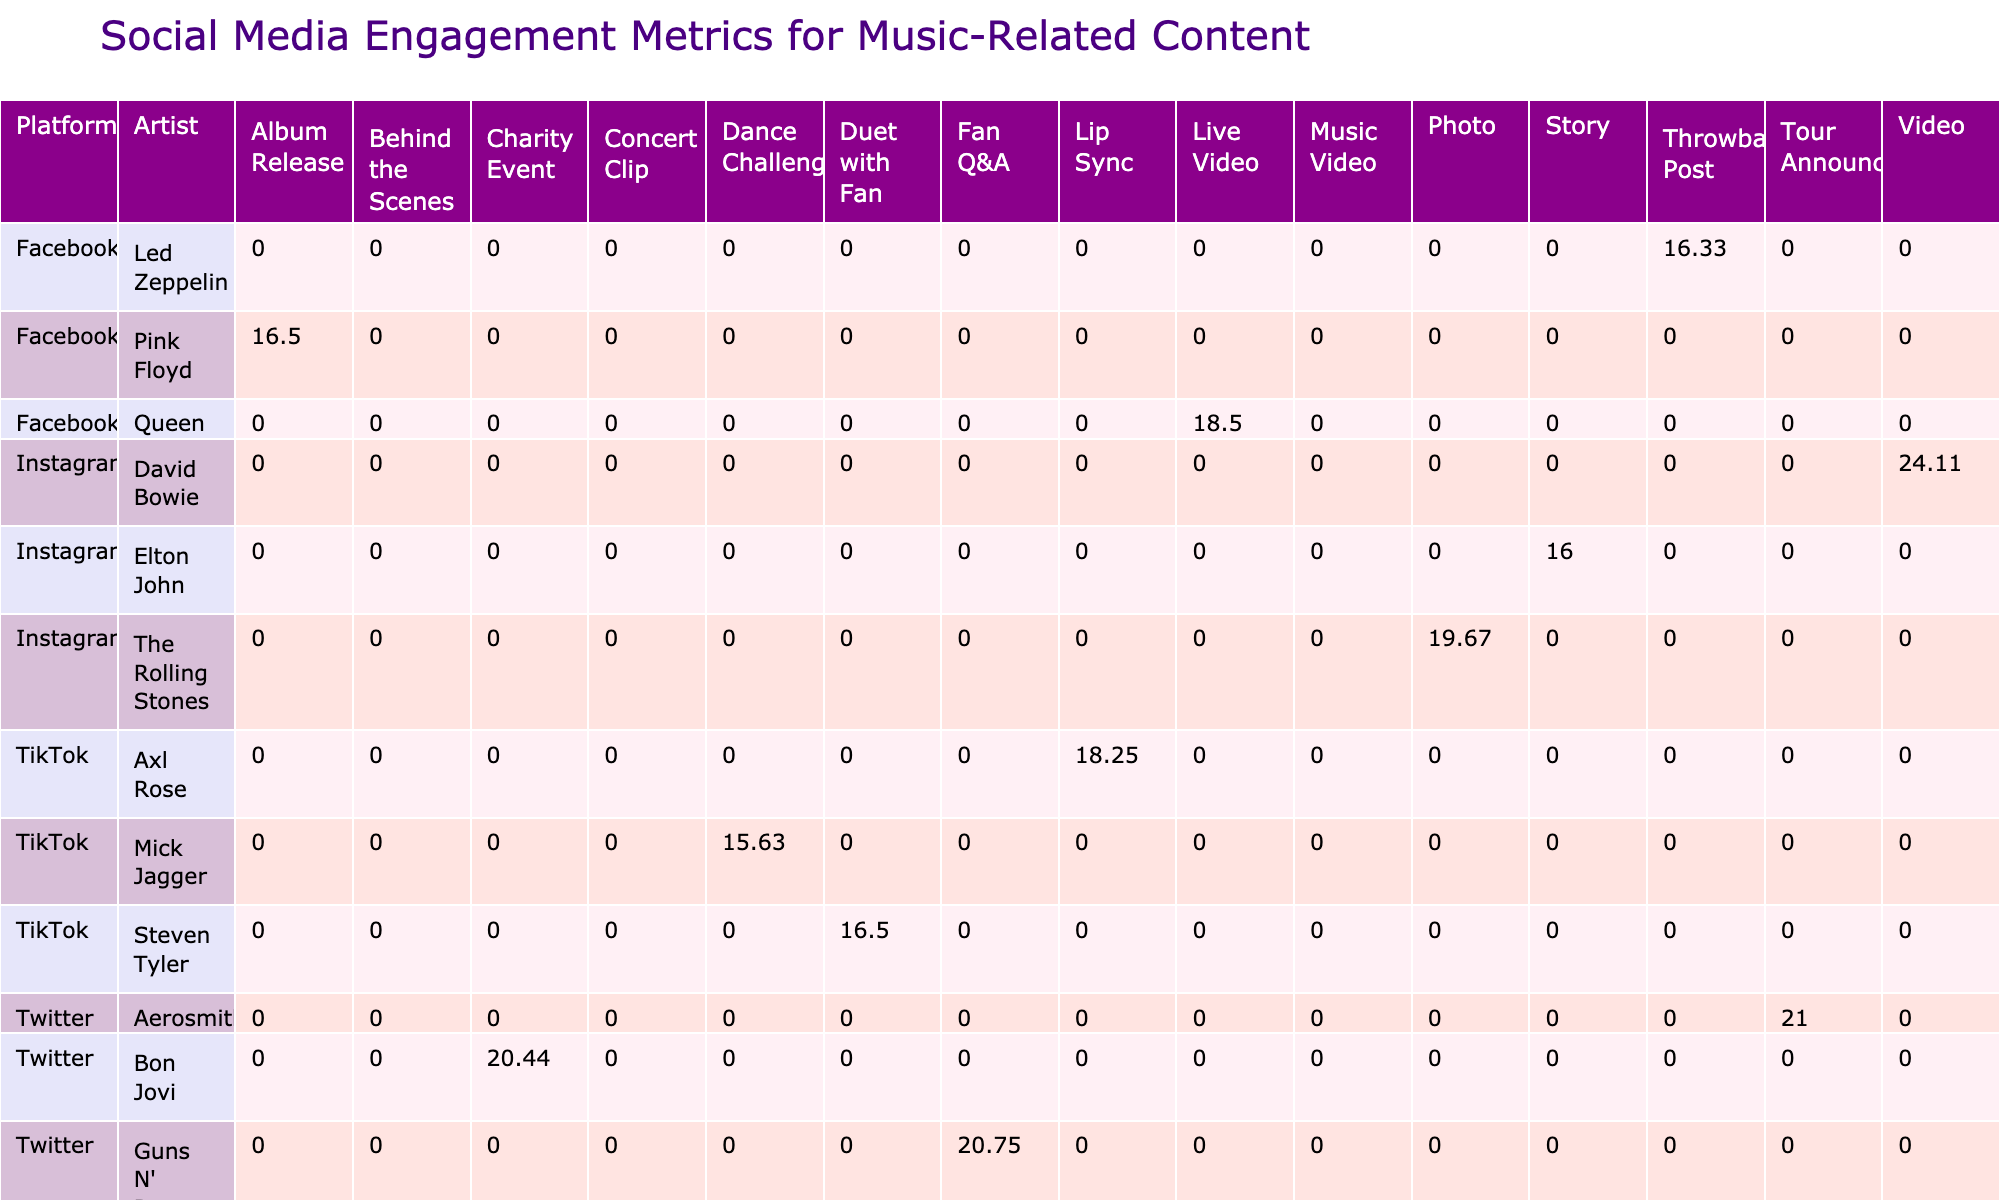What is the highest engagement rate observed in the table? By scanning through the Engagement Rate column, I find the highest value, which is 24.11 from the artist David Bowie on Instagram.
Answer: 24.11 Which platform has the most content types represented in this table? To determine this, I count how many unique Content Types are listed for each platform. Instagram has three types (Photo, Video, Story), Facebook has three types (Live Video, Album Release, Throwback Post), Twitter has three types (Tour Announcement, Fan Q&A, Charity Event), YouTube has three types (Music Video, Concert Clip, Behind the Scenes), and TikTok has three types (Dance Challenge, Duet with Fan, Lip Sync). Since all platforms have the same number of content types, the answer is all platforms have equal representation.
Answer: All platforms have equal representation What is the average engagement rate for TikTok content? I sum the engagement rates for all TikTok entries (15.63, 16.50, and 18.25), which totals 50.38. Then, I divide this sum by 3, the number of entries for TikTok, to find the average: 50.38/3 = 16.79.
Answer: 16.79 Did any artist have an engagement rate higher than 20? I review the Engagement Rate column and find that David Bowie (24.11), Aerosmith (21.00), Guns N' Roses (20.75), and Axl Rose (18.25) have rates higher than 20. Therefore, yes, there are multiple artists with this threshold.
Answer: Yes Which artist on Facebook received the highest number of likes? I inspect the Likes column for the Facebook entries only and find that Queen received 300000 likes, which is the highest among the Facebook artists listed.
Answer: Queen 